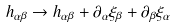<formula> <loc_0><loc_0><loc_500><loc_500>h _ { \alpha \beta } \rightarrow h _ { \alpha \beta } + \partial _ { \alpha } \xi _ { \beta } + \partial _ { \beta } \xi _ { \alpha }</formula> 